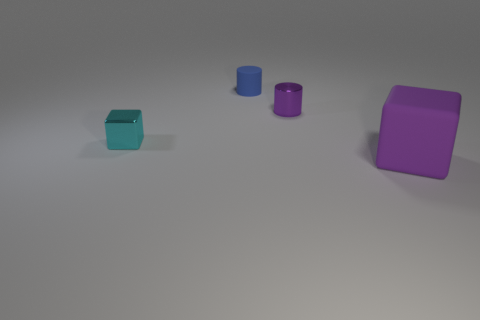Subtract all brown cubes. Subtract all cyan cylinders. How many cubes are left? 2 Add 2 blue cylinders. How many objects exist? 6 Subtract 0 gray cubes. How many objects are left? 4 Subtract all blue rubber spheres. Subtract all small blue rubber cylinders. How many objects are left? 3 Add 2 tiny blocks. How many tiny blocks are left? 3 Add 4 tiny gray rubber blocks. How many tiny gray rubber blocks exist? 4 